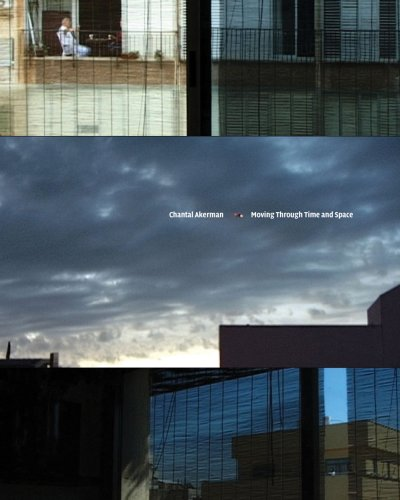Is this an art related book? Yes, this book delves into the artistic processes and visual styles of Chantal Akerman, highlighting her influential role in modern visual arts. 